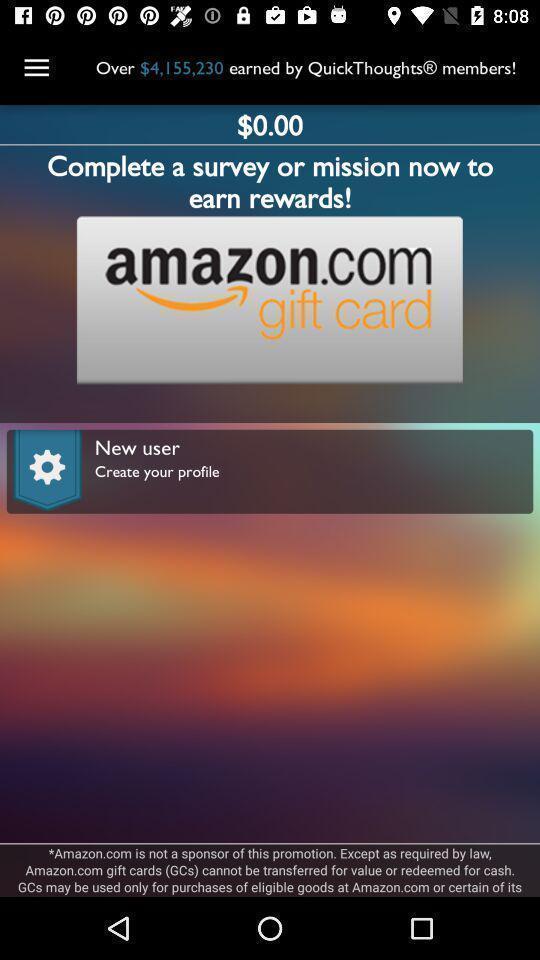What details can you identify in this image? Page displaying information about survey. 